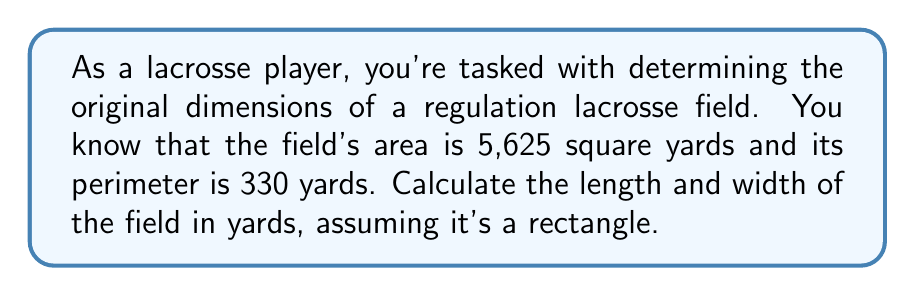Solve this math problem. Let's approach this step-by-step:

1) Let $l$ be the length and $w$ be the width of the field.

2) Given information:
   Area: $A = lw = 5,625$ sq yards
   Perimeter: $P = 2l + 2w = 330$ yards

3) From the perimeter equation:
   $l = 165 - w$ (Equation 1)

4) Substitute this into the area equation:
   $A = w(165 - w) = 5,625$

5) Expand:
   $165w - w^2 = 5,625$

6) Rearrange to standard quadratic form:
   $w^2 - 165w + 5,625 = 0$

7) Use the quadratic formula: $w = \frac{-b \pm \sqrt{b^2 - 4ac}}{2a}$
   Where $a=1$, $b=-165$, and $c=5,625$

8) Solving:
   $w = \frac{165 \pm \sqrt{165^2 - 4(1)(5,625)}}{2(1)}$
   $w = \frac{165 \pm \sqrt{27,225 - 22,500}}{2}$
   $w = \frac{165 \pm \sqrt{4,725}}{2}$
   $w = \frac{165 \pm 68.74}{2}$

9) This gives us two solutions:
   $w_1 = \frac{165 + 68.74}{2} = 116.87$ yards
   $w_2 = \frac{165 - 68.74}{2} = 48.13$ yards

10) Using Equation 1, we can find the corresponding lengths:
    $l_1 = 165 - 116.87 = 48.13$ yards
    $l_2 = 165 - 48.13 = 116.87$ yards

11) Both solutions (116.87 x 48.13) and (48.13 x 116.87) satisfy our conditions. However, knowing that a regulation lacrosse field is longer than it is wide, we choose the second solution.
Answer: Length: 116.87 yards, Width: 48.13 yards 